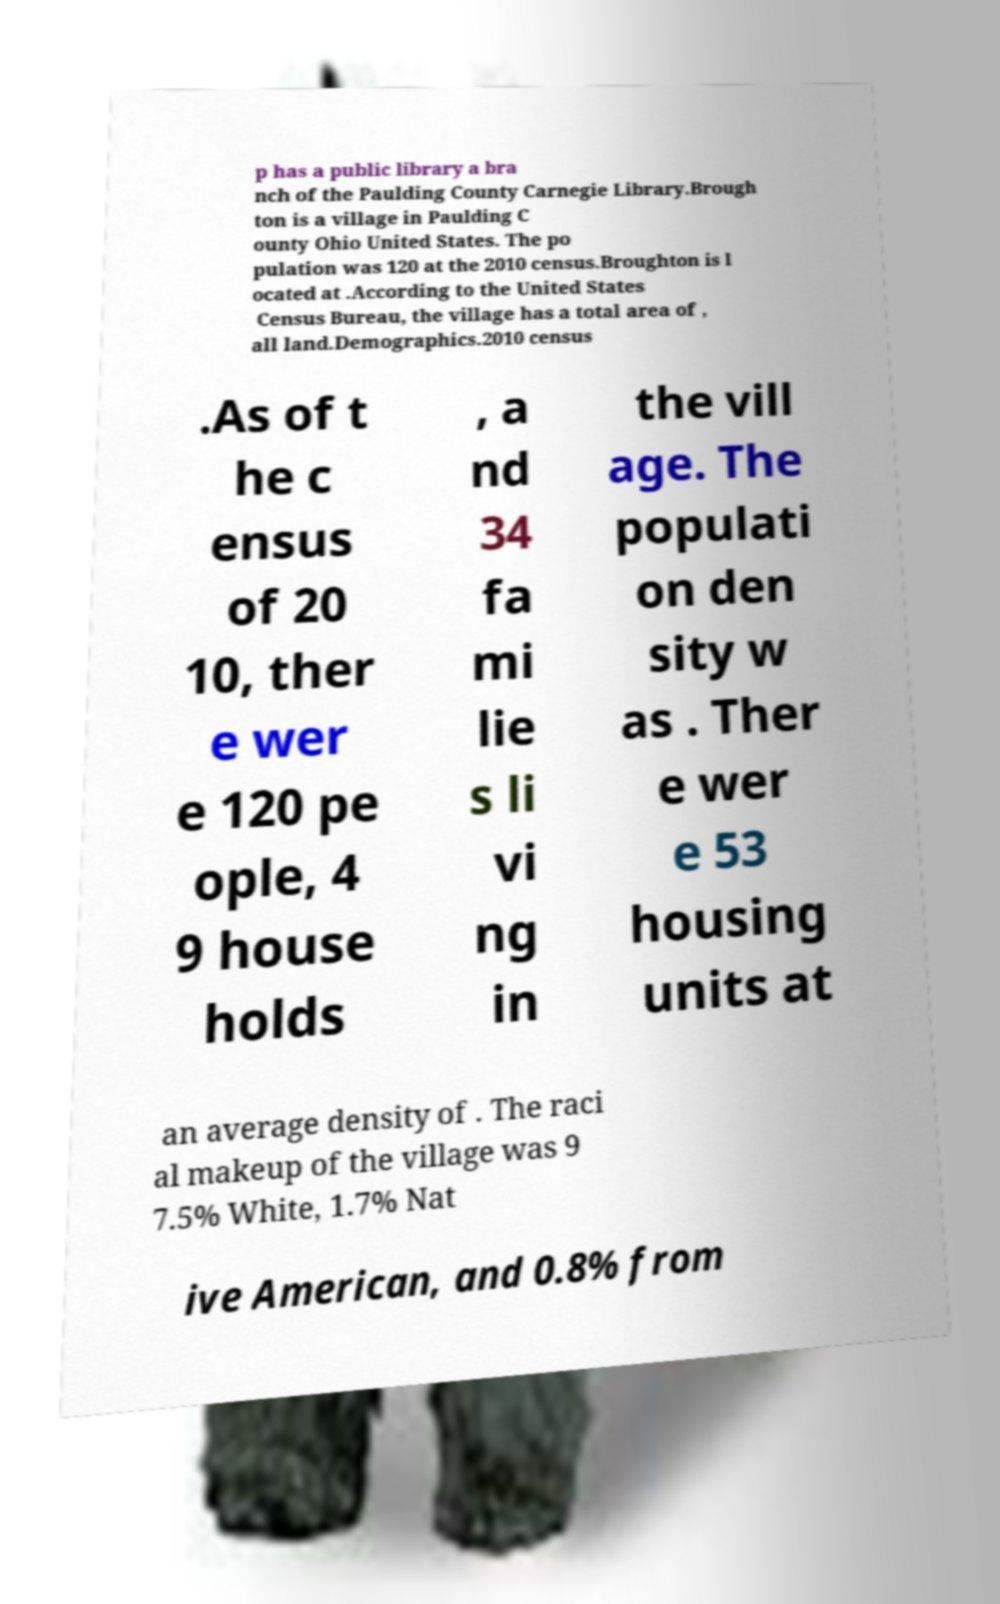For documentation purposes, I need the text within this image transcribed. Could you provide that? p has a public library a bra nch of the Paulding County Carnegie Library.Brough ton is a village in Paulding C ounty Ohio United States. The po pulation was 120 at the 2010 census.Broughton is l ocated at .According to the United States Census Bureau, the village has a total area of , all land.Demographics.2010 census .As of t he c ensus of 20 10, ther e wer e 120 pe ople, 4 9 house holds , a nd 34 fa mi lie s li vi ng in the vill age. The populati on den sity w as . Ther e wer e 53 housing units at an average density of . The raci al makeup of the village was 9 7.5% White, 1.7% Nat ive American, and 0.8% from 